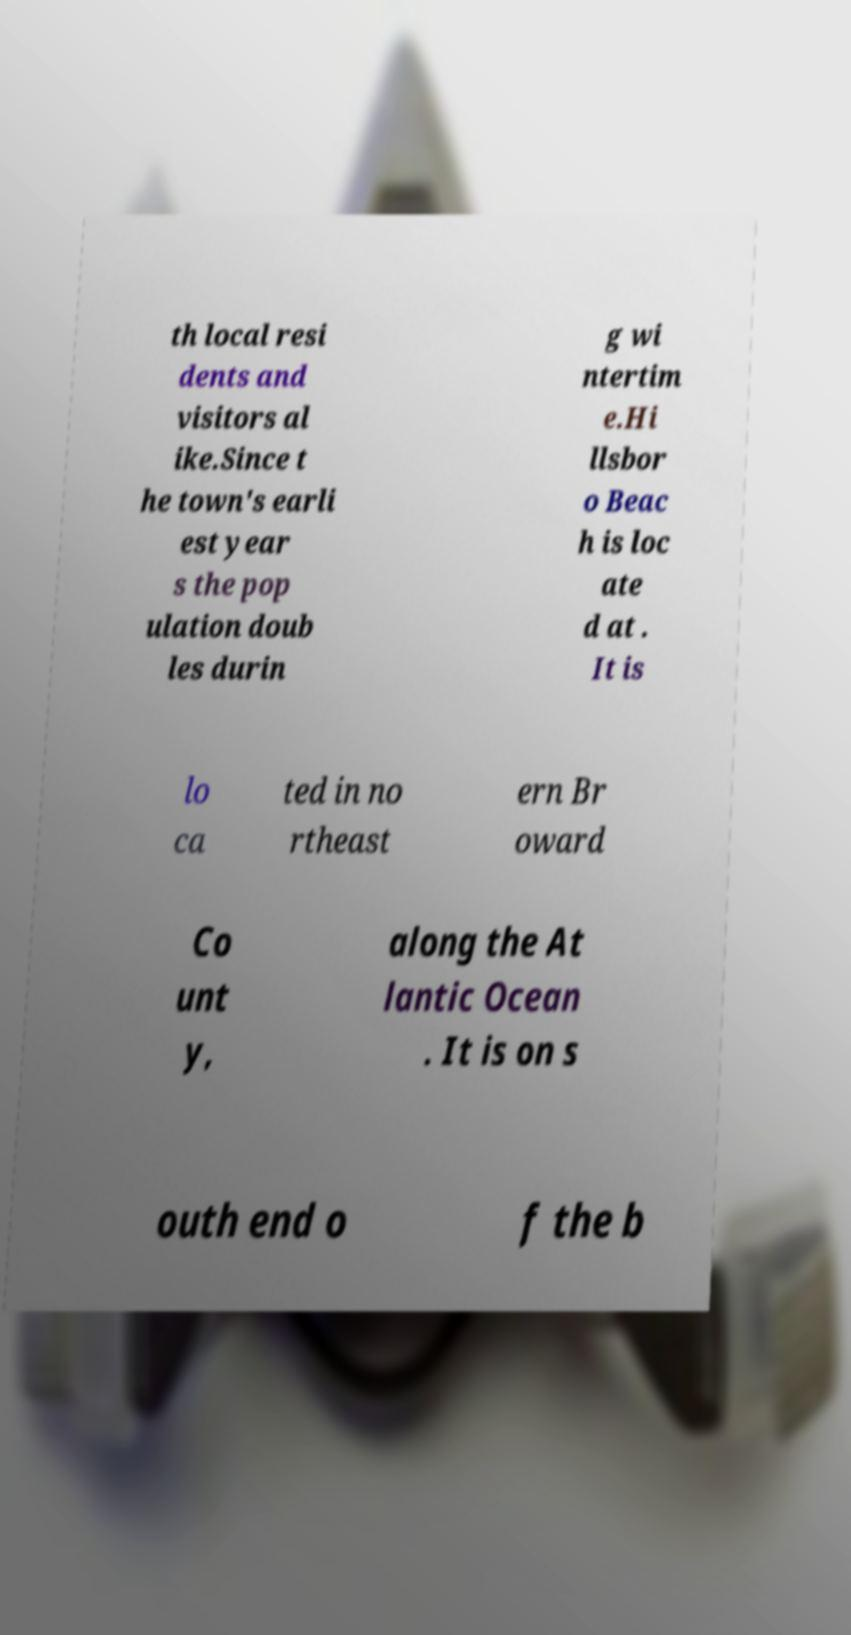For documentation purposes, I need the text within this image transcribed. Could you provide that? th local resi dents and visitors al ike.Since t he town's earli est year s the pop ulation doub les durin g wi ntertim e.Hi llsbor o Beac h is loc ate d at . It is lo ca ted in no rtheast ern Br oward Co unt y, along the At lantic Ocean . It is on s outh end o f the b 